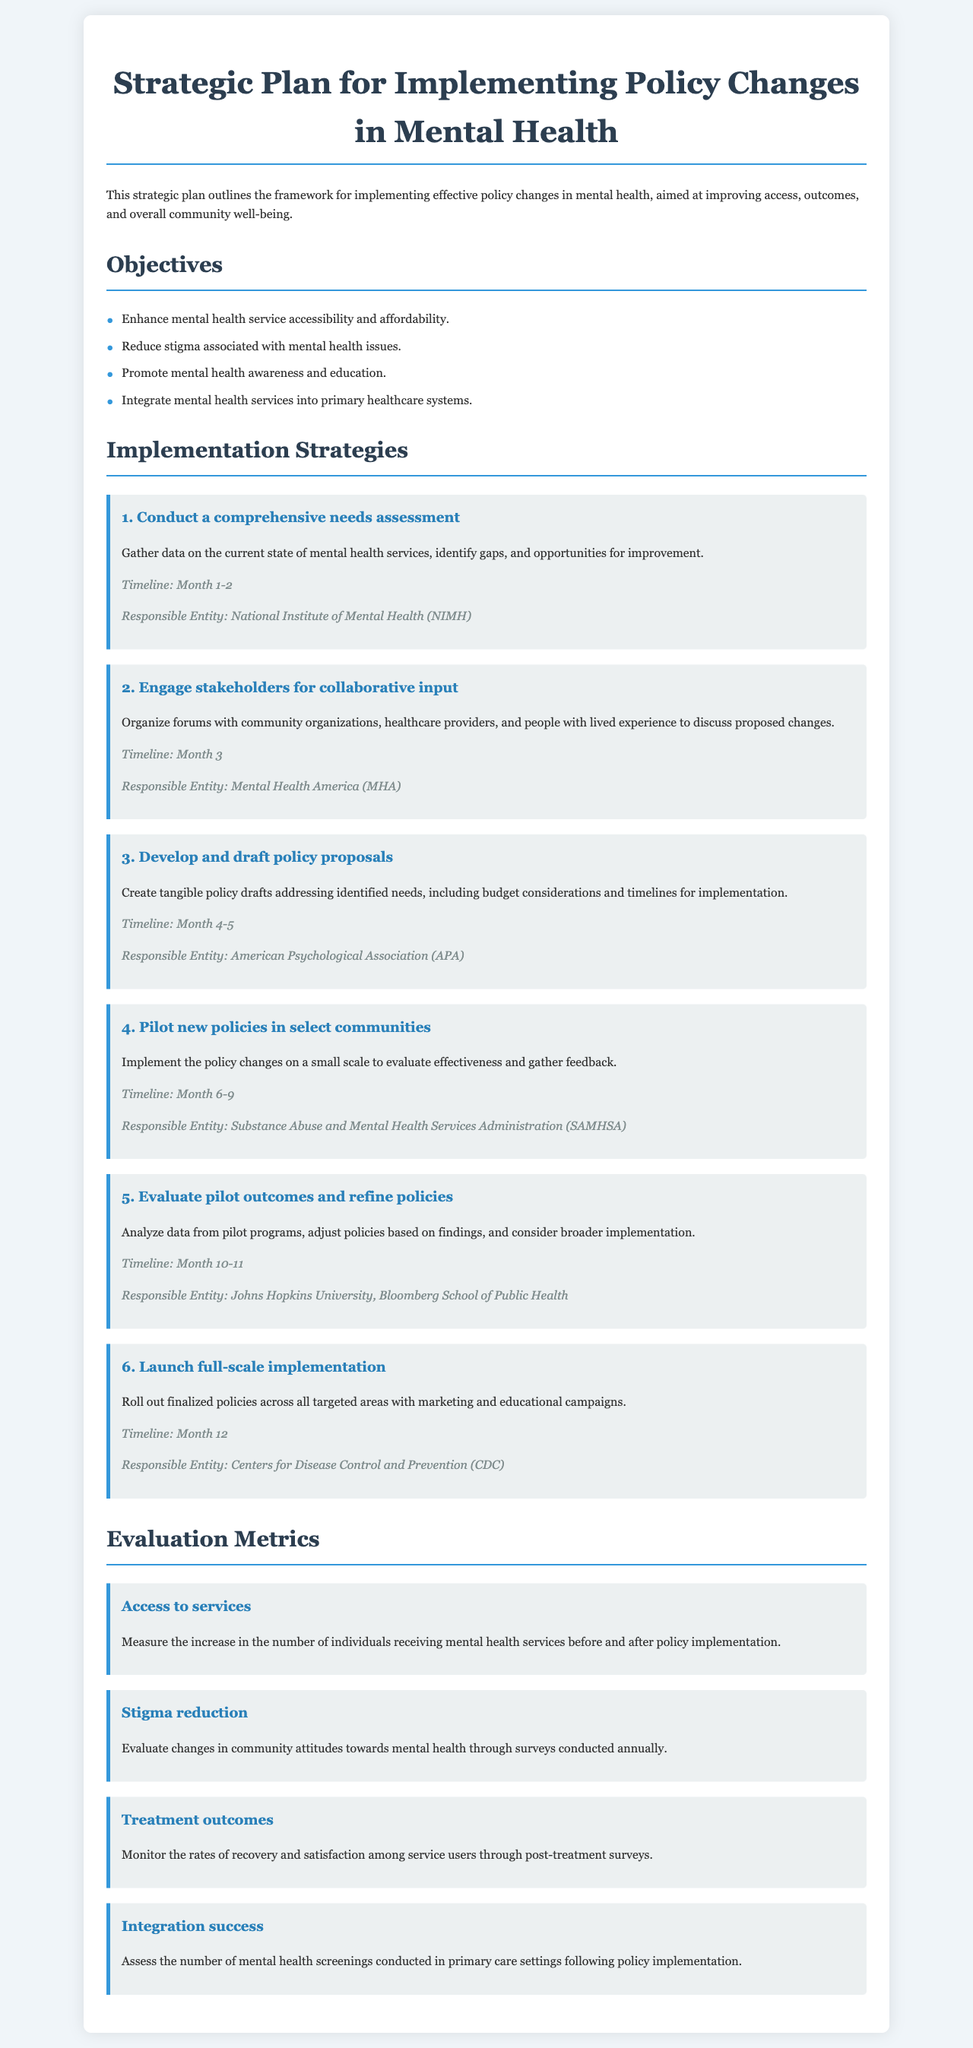What are the objectives of the strategic plan? The objectives are the goals outlined in the document aimed at improving mental health services.
Answer: Enhance mental health service accessibility and affordability, Reduce stigma associated with mental health issues, Promote mental health awareness and education, Integrate mental health services into primary healthcare systems Who is responsible for conducting a comprehensive needs assessment? This question identifies the entity tasked with carrying out the needs assessment as per the strategic plan.
Answer: National Institute of Mental Health (NIMH) What is the timeline for piloting new policies? The timeline indicates the duration during which the policies will be tested in select communities.
Answer: Month 6-9 How many months are allocated for the evaluation of pilot outcomes? This question seeks to determine the duration set for analyzing the pilot program results according to the timeline.
Answer: 2 months What is one of the evaluation metrics used in the strategic plan? This question asks for an example of how outcomes will be measured after policy implementation.
Answer: Access to services What is the primary goal of the strategy to engage stakeholders? The question focuses on the purpose of the stakeholder engagement strategy within the broader implementation plan.
Answer: Collaborative input What months are designated for developing and drafting policy proposals? This question highlights the timeframe allocated for creating policy proposals.
Answer: Month 4-5 What agency is responsible for launching full-scale implementation? This question identifies the organization responsible for the rollout of finalized policies.
Answer: Centers for Disease Control and Prevention (CDC) 